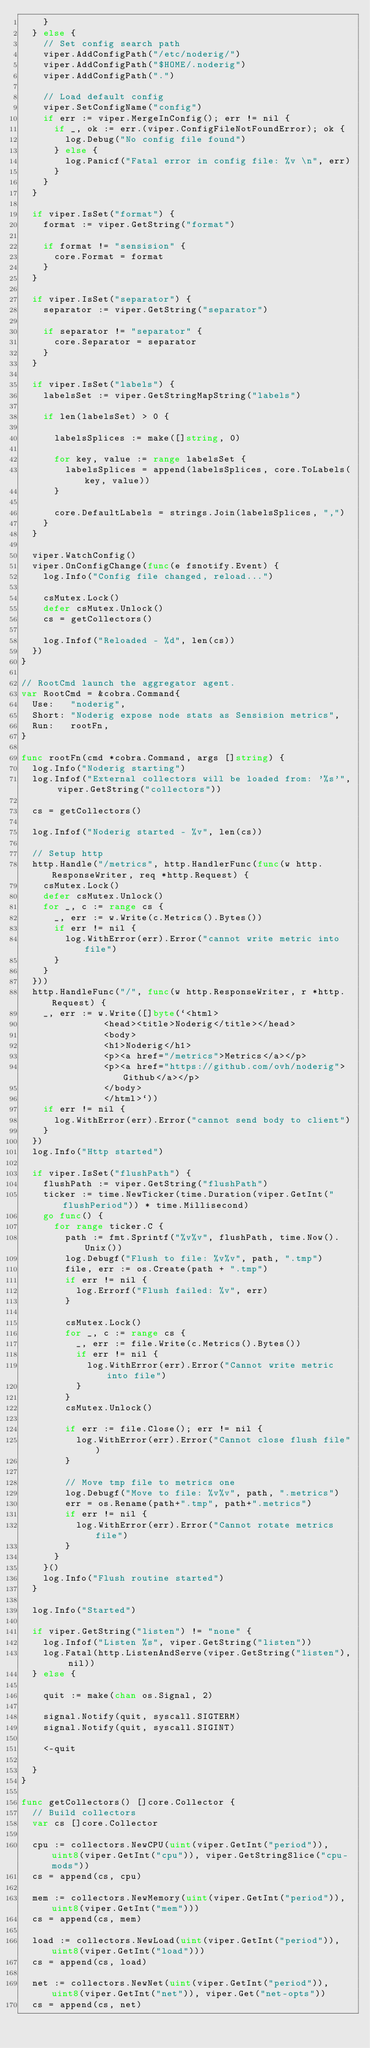Convert code to text. <code><loc_0><loc_0><loc_500><loc_500><_Go_>		}
	} else {
		// Set config search path
		viper.AddConfigPath("/etc/noderig/")
		viper.AddConfigPath("$HOME/.noderig")
		viper.AddConfigPath(".")

		// Load default config
		viper.SetConfigName("config")
		if err := viper.MergeInConfig(); err != nil {
			if _, ok := err.(viper.ConfigFileNotFoundError); ok {
				log.Debug("No config file found")
			} else {
				log.Panicf("Fatal error in config file: %v \n", err)
			}
		}
	}

	if viper.IsSet("format") {
		format := viper.GetString("format")

		if format != "sensision" {
			core.Format = format
		}
	}

	if viper.IsSet("separator") {
		separator := viper.GetString("separator")

		if separator != "separator" {
			core.Separator = separator
		}
	}

	if viper.IsSet("labels") {
		labelsSet := viper.GetStringMapString("labels")

		if len(labelsSet) > 0 {

			labelsSplices := make([]string, 0)

			for key, value := range labelsSet {
				labelsSplices = append(labelsSplices, core.ToLabels(key, value))
			}

			core.DefaultLabels = strings.Join(labelsSplices, ",")
		}
	}

	viper.WatchConfig()
	viper.OnConfigChange(func(e fsnotify.Event) {
		log.Info("Config file changed, reload...")

		csMutex.Lock()
		defer csMutex.Unlock()
		cs = getCollectors()

		log.Infof("Reloaded - %d", len(cs))
	})
}

// RootCmd launch the aggregator agent.
var RootCmd = &cobra.Command{
	Use:   "noderig",
	Short: "Noderig expose node stats as Sensision metrics",
	Run:   rootFn,
}

func rootFn(cmd *cobra.Command, args []string) {
	log.Info("Noderig starting")
	log.Infof("External collectors will be loaded from: '%s'", viper.GetString("collectors"))

	cs = getCollectors()

	log.Infof("Noderig started - %v", len(cs))

	// Setup http
	http.Handle("/metrics", http.HandlerFunc(func(w http.ResponseWriter, req *http.Request) {
		csMutex.Lock()
		defer csMutex.Unlock()
		for _, c := range cs {
			_, err := w.Write(c.Metrics().Bytes())
			if err != nil {
				log.WithError(err).Error("cannot write metric into file")
			}
		}
	}))
	http.HandleFunc("/", func(w http.ResponseWriter, r *http.Request) {
		_, err := w.Write([]byte(`<html>
	             <head><title>Noderig</title></head>
	             <body>
	             <h1>Noderig</h1>
	             <p><a href="/metrics">Metrics</a></p>
	             <p><a href="https://github.com/ovh/noderig">Github</a></p>
	             </body>
	             </html>`))
		if err != nil {
			log.WithError(err).Error("cannot send body to client")
		}
	})
	log.Info("Http started")

	if viper.IsSet("flushPath") {
		flushPath := viper.GetString("flushPath")
		ticker := time.NewTicker(time.Duration(viper.GetInt("flushPeriod")) * time.Millisecond)
		go func() {
			for range ticker.C {
				path := fmt.Sprintf("%v%v", flushPath, time.Now().Unix())
				log.Debugf("Flush to file: %v%v", path, ".tmp")
				file, err := os.Create(path + ".tmp")
				if err != nil {
					log.Errorf("Flush failed: %v", err)
				}

				csMutex.Lock()
				for _, c := range cs {
					_, err := file.Write(c.Metrics().Bytes())
					if err != nil {
						log.WithError(err).Error("Cannot write metric into file")
					}
				}
				csMutex.Unlock()

				if err := file.Close(); err != nil {
					log.WithError(err).Error("Cannot close flush file")
				}

				// Move tmp file to metrics one
				log.Debugf("Move to file: %v%v", path, ".metrics")
				err = os.Rename(path+".tmp", path+".metrics")
				if err != nil {
					log.WithError(err).Error("Cannot rotate metrics file")
				}
			}
		}()
		log.Info("Flush routine started")
	}

	log.Info("Started")

	if viper.GetString("listen") != "none" {
		log.Infof("Listen %s", viper.GetString("listen"))
		log.Fatal(http.ListenAndServe(viper.GetString("listen"), nil))
	} else {

		quit := make(chan os.Signal, 2)

		signal.Notify(quit, syscall.SIGTERM)
		signal.Notify(quit, syscall.SIGINT)

		<-quit

	}
}

func getCollectors() []core.Collector {
	// Build collectors
	var cs []core.Collector

	cpu := collectors.NewCPU(uint(viper.GetInt("period")), uint8(viper.GetInt("cpu")), viper.GetStringSlice("cpu-mods"))
	cs = append(cs, cpu)

	mem := collectors.NewMemory(uint(viper.GetInt("period")), uint8(viper.GetInt("mem")))
	cs = append(cs, mem)

	load := collectors.NewLoad(uint(viper.GetInt("period")), uint8(viper.GetInt("load")))
	cs = append(cs, load)

	net := collectors.NewNet(uint(viper.GetInt("period")), uint8(viper.GetInt("net")), viper.Get("net-opts"))
	cs = append(cs, net)
</code> 